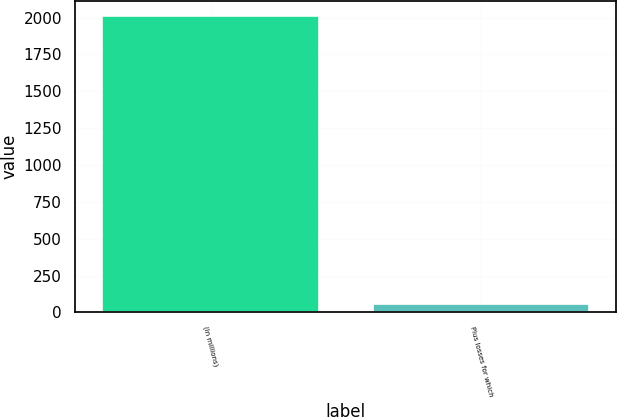Convert chart to OTSL. <chart><loc_0><loc_0><loc_500><loc_500><bar_chart><fcel>(In millions)<fcel>Plus losses for which<nl><fcel>2011<fcel>55<nl></chart> 